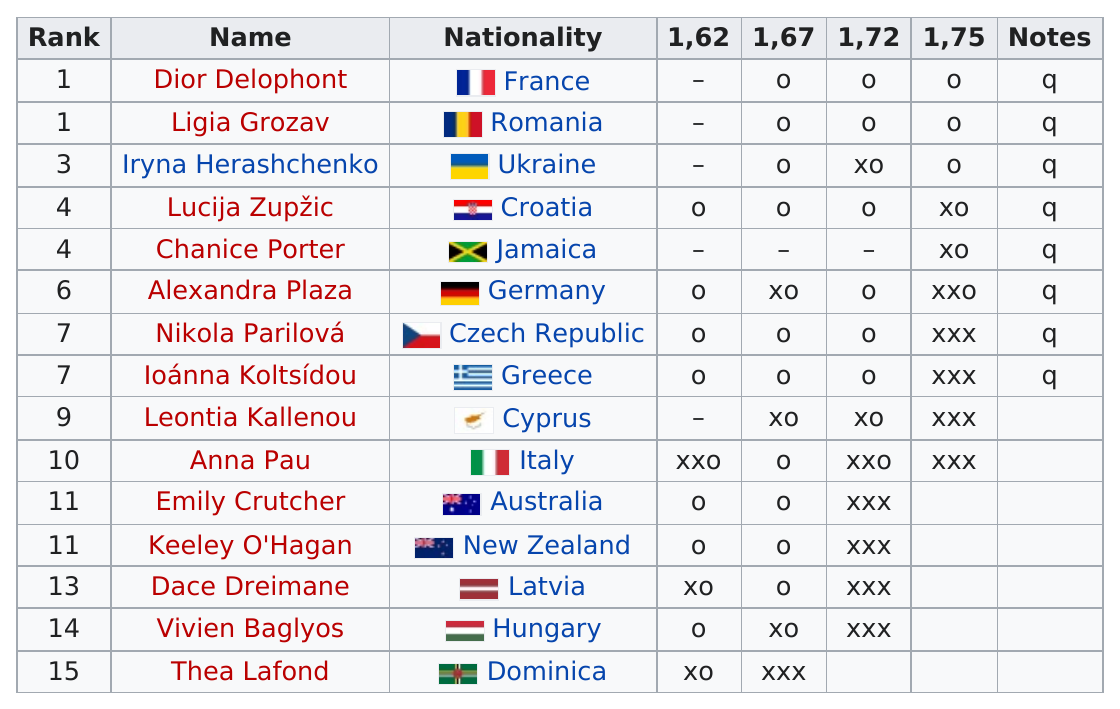Draw attention to some important aspects in this diagram. The first person of rank 1 to qualify is Dior Delophont. Leontia Kallenou is the previous qualifier over Anna Pau. Thea Lafond was the last ranked competitor in group A. The first name listed is Dior Delophont. It is more common for people to be ranked 11th than 6th. 